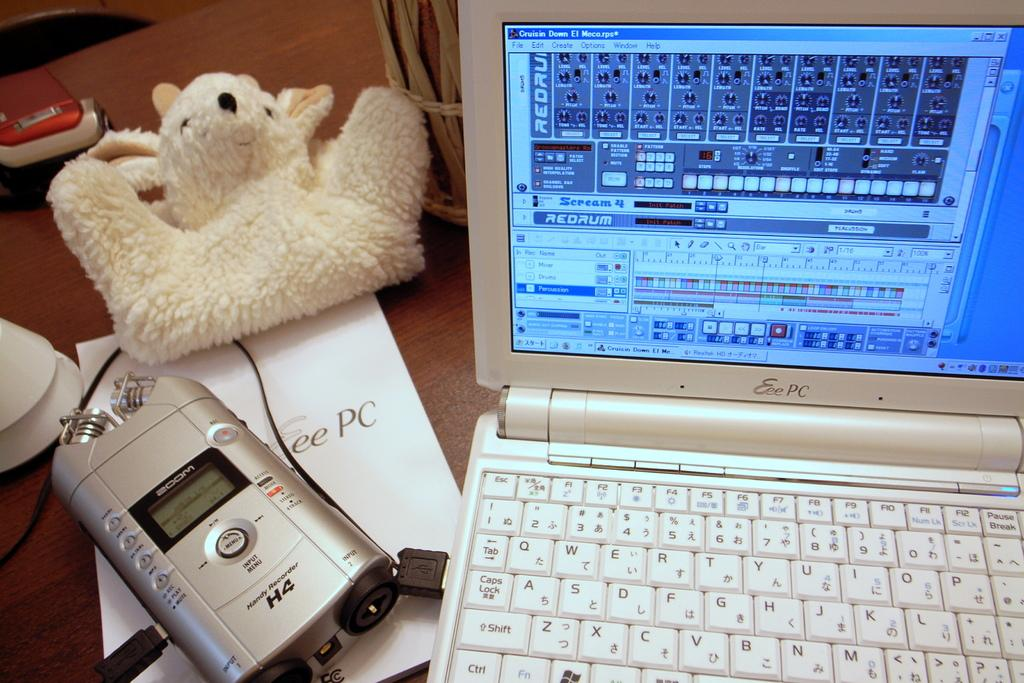<image>
Offer a succinct explanation of the picture presented. a computer open to a screen with REDRUM on it 